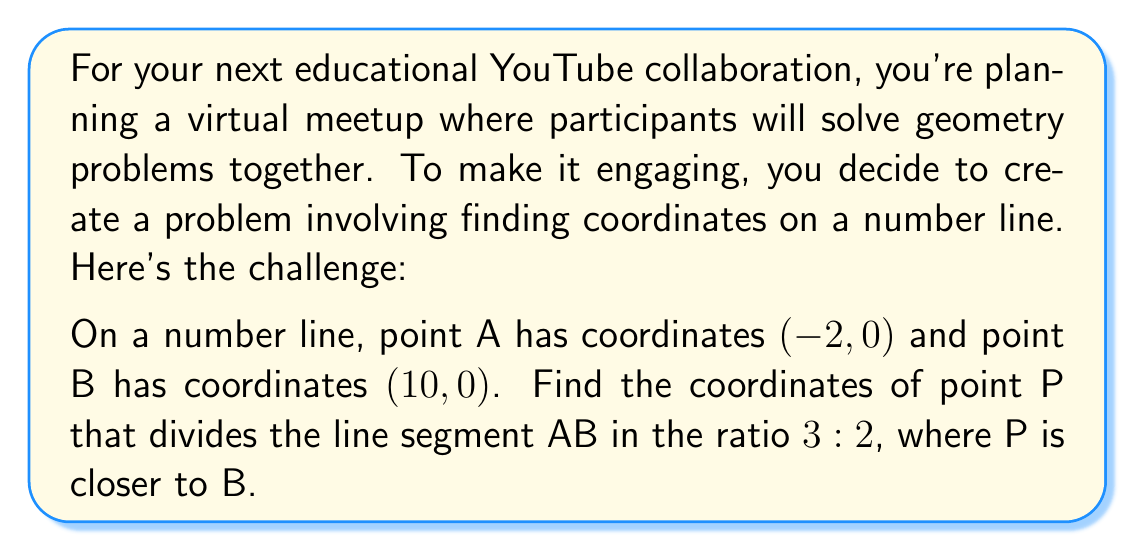Show me your answer to this math problem. Let's solve this step-by-step:

1) We can use the section formula to find the coordinates of point P. The formula is:

   $$(x, y) = \left(\frac{m x_2 + n x_1}{m + n}, \frac{m y_2 + n y_1}{m + n}\right)$$

   where $(x_1, y_1)$ and $(x_2, y_2)$ are the coordinates of the endpoints, and $m:n$ is the ratio in which the point divides the line segment.

2) In this case:
   - $(x_1, y_1) = (-2, 0)$ (point A)
   - $(x_2, y_2) = (10, 0)$ (point B)
   - The ratio is 3:2, but P is closer to B, so $m = 2$ and $n = 3$

3) Let's substitute these into the formula:

   $$x = \frac{2(10) + 3(-2)}{2 + 3} = \frac{20 - 6}{5} = \frac{14}{5} = 2.8$$

   $$y = \frac{2(0) + 3(0)}{2 + 3} = 0$$

4) Therefore, the coordinates of point P are (2.8, 0).
Answer: (2.8, 0) 